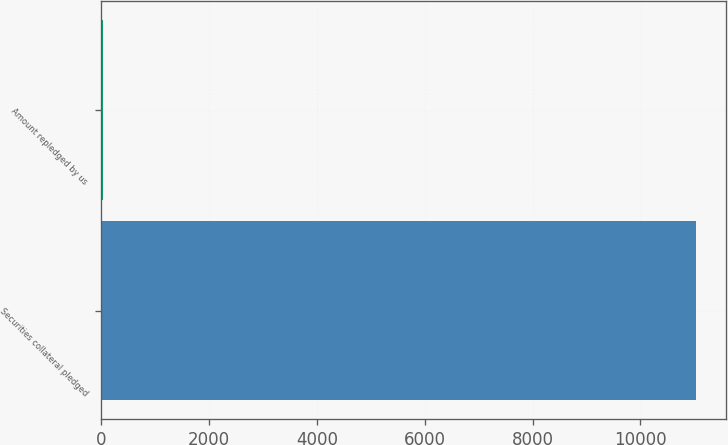<chart> <loc_0><loc_0><loc_500><loc_500><bar_chart><fcel>Securities collateral pledged<fcel>Amount repledged by us<nl><fcel>11039<fcel>33<nl></chart> 